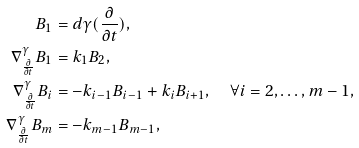Convert formula to latex. <formula><loc_0><loc_0><loc_500><loc_500>B _ { 1 } & = d \gamma ( \frac { \partial } { \partial t } ) , \\ \nabla _ { \frac { \partial } { \partial t } } ^ { \gamma } B _ { 1 } & = k _ { 1 } B _ { 2 } , \\ \nabla _ { \frac { \partial } { \partial t } } ^ { \gamma } B _ { i } & = - k _ { i - 1 } B _ { i - 1 } + k _ { i } B _ { i + 1 } , \quad \forall i = 2 , \dots , m - 1 , \\ \nabla _ { \frac { \partial } { \partial t } } ^ { \gamma } B _ { m } & = - k _ { m - 1 } B _ { m - 1 } ,</formula> 